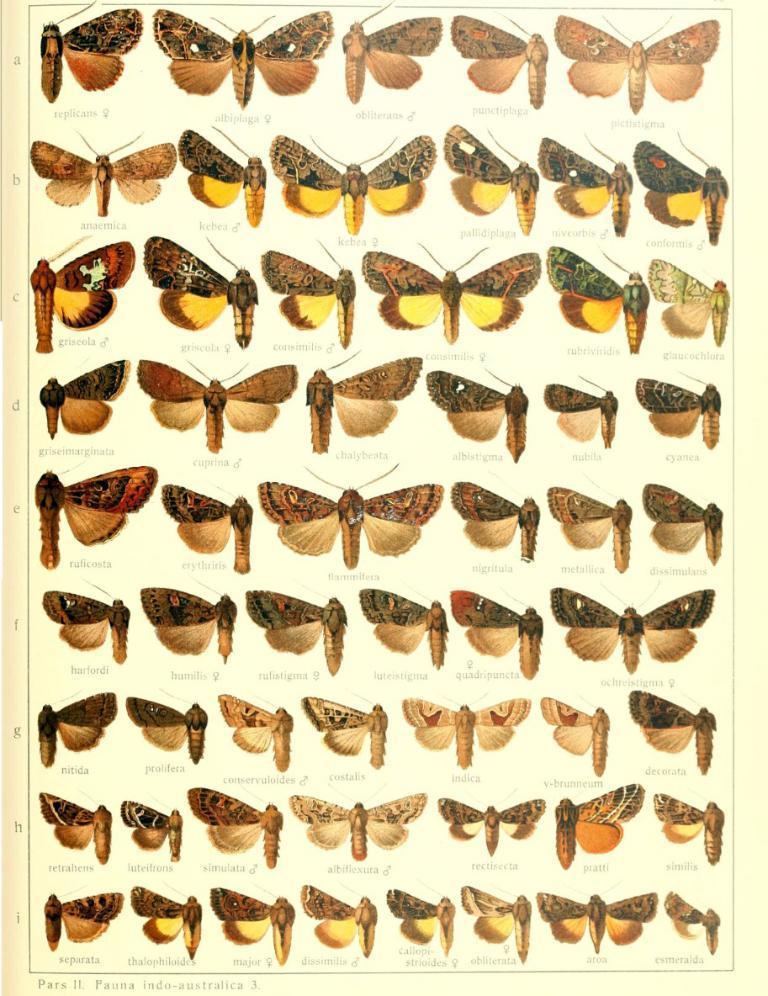In one or two sentences, can you explain what this image depicts? In this picture there are images of butterflies and some text on each butterfly. 